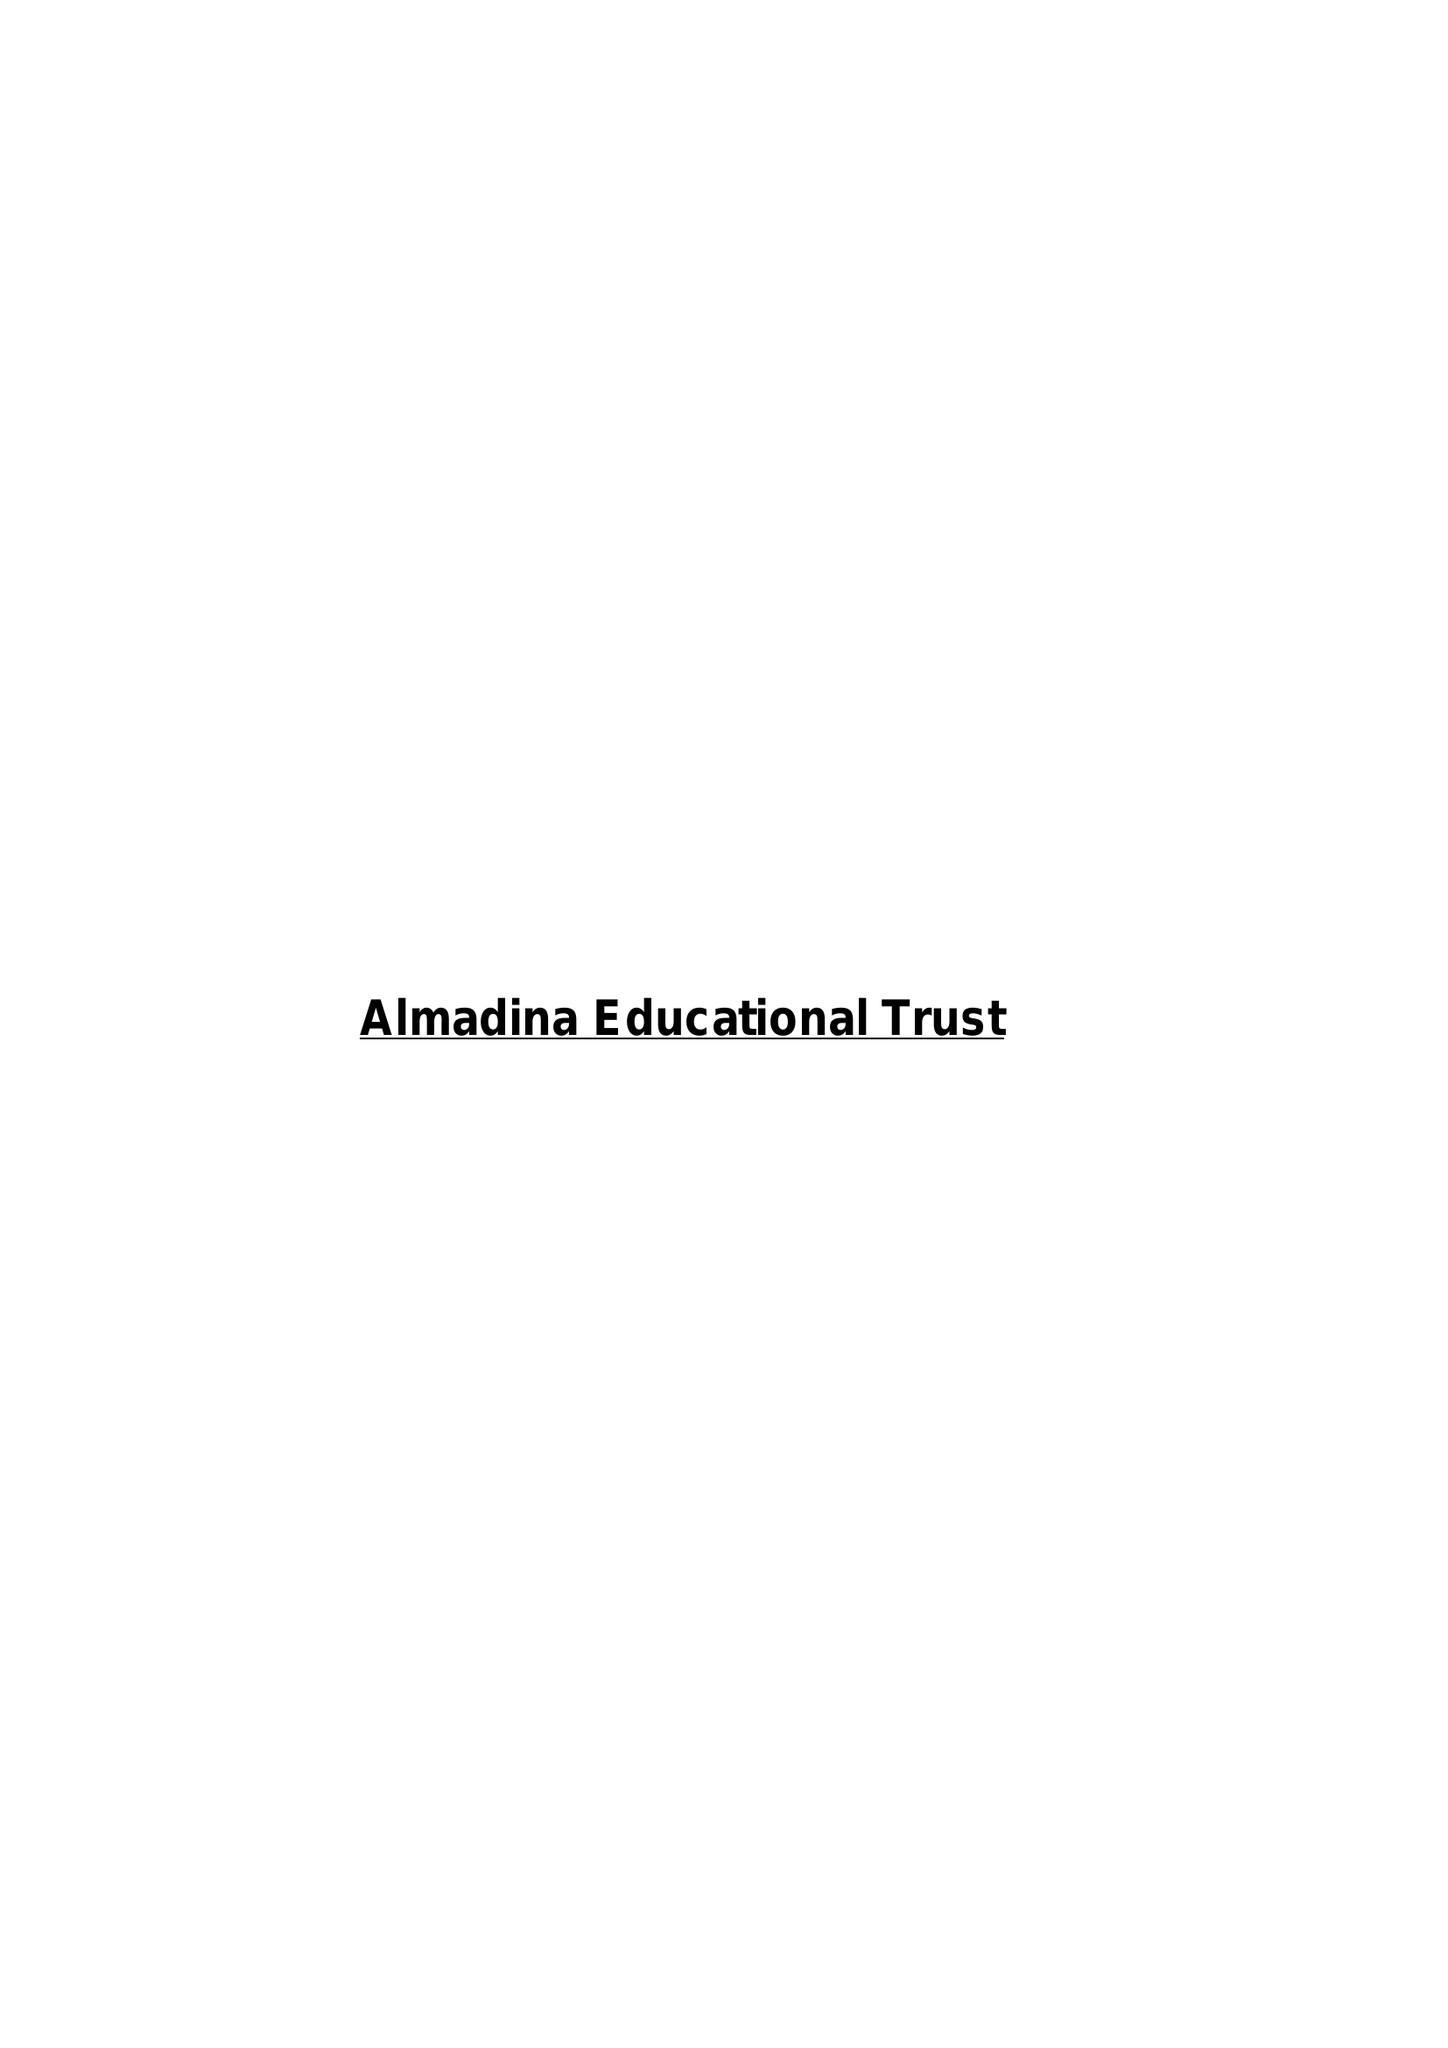What is the value for the report_date?
Answer the question using a single word or phrase. 2017-07-31 